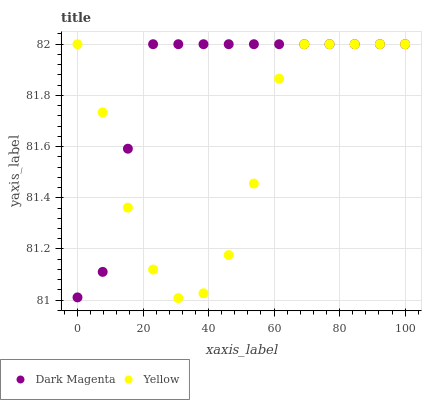Does Yellow have the minimum area under the curve?
Answer yes or no. Yes. Does Dark Magenta have the maximum area under the curve?
Answer yes or no. Yes. Does Yellow have the maximum area under the curve?
Answer yes or no. No. Is Dark Magenta the smoothest?
Answer yes or no. Yes. Is Yellow the roughest?
Answer yes or no. Yes. Is Yellow the smoothest?
Answer yes or no. No. Does Yellow have the lowest value?
Answer yes or no. Yes. Does Yellow have the highest value?
Answer yes or no. Yes. Does Dark Magenta intersect Yellow?
Answer yes or no. Yes. Is Dark Magenta less than Yellow?
Answer yes or no. No. Is Dark Magenta greater than Yellow?
Answer yes or no. No. 